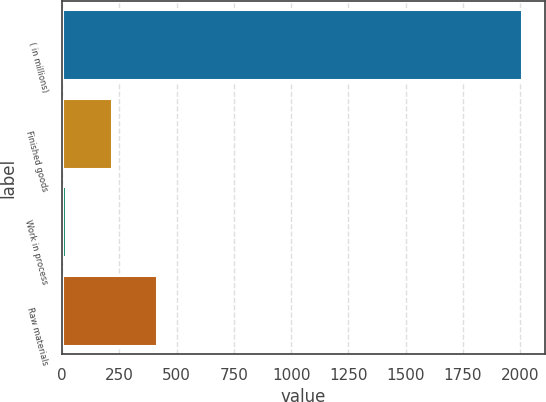Convert chart. <chart><loc_0><loc_0><loc_500><loc_500><bar_chart><fcel>( in millions)<fcel>Finished goods<fcel>Work in process<fcel>Raw materials<nl><fcel>2008<fcel>217.72<fcel>18.8<fcel>416.64<nl></chart> 